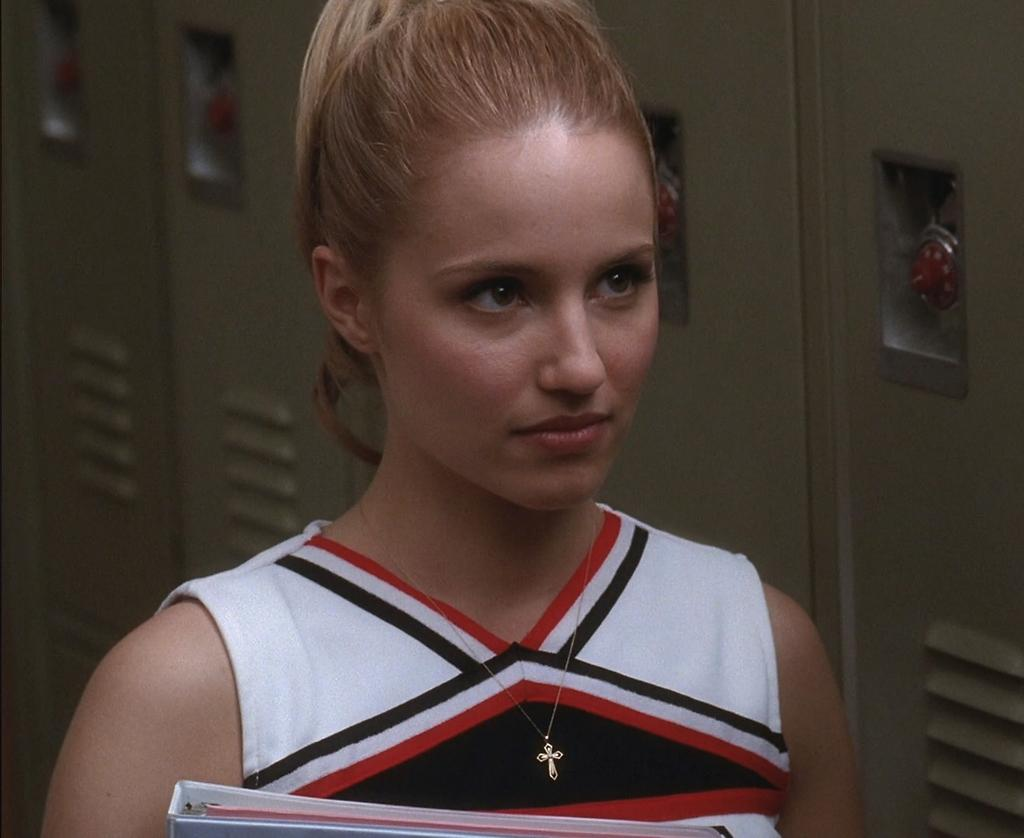Who is present in the image? There is a woman in the image. What is the woman wearing? The woman is wearing a dress with white, black, and red colors. What is the woman holding in her hand? The woman is holding a file in her hand. What can be seen in the background of the image? There are lockers visible in the background of the image. How does the woman compare her performance in the game to her previous records in the image? There is no game or performance mentioned in the image, so it is not possible to answer that question. 